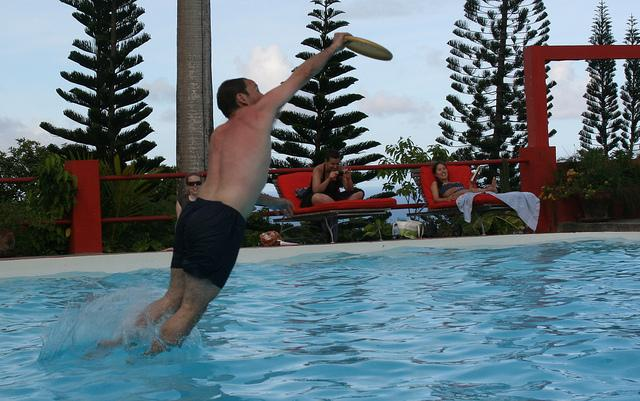Where is the man while he is swimming?

Choices:
A) in ocean
B) in pool
C) in river
D) in lake in pool 